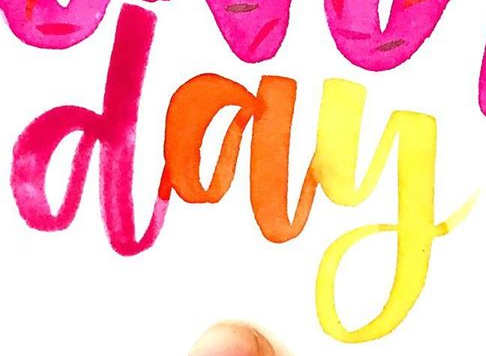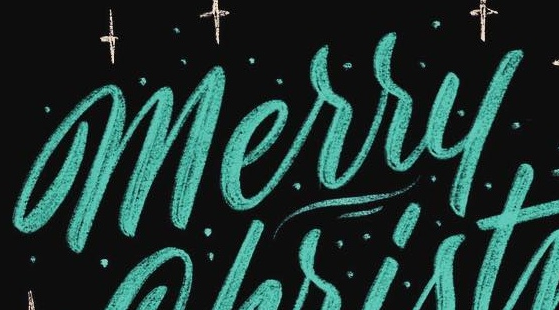Read the text from these images in sequence, separated by a semicolon. day; Merry 